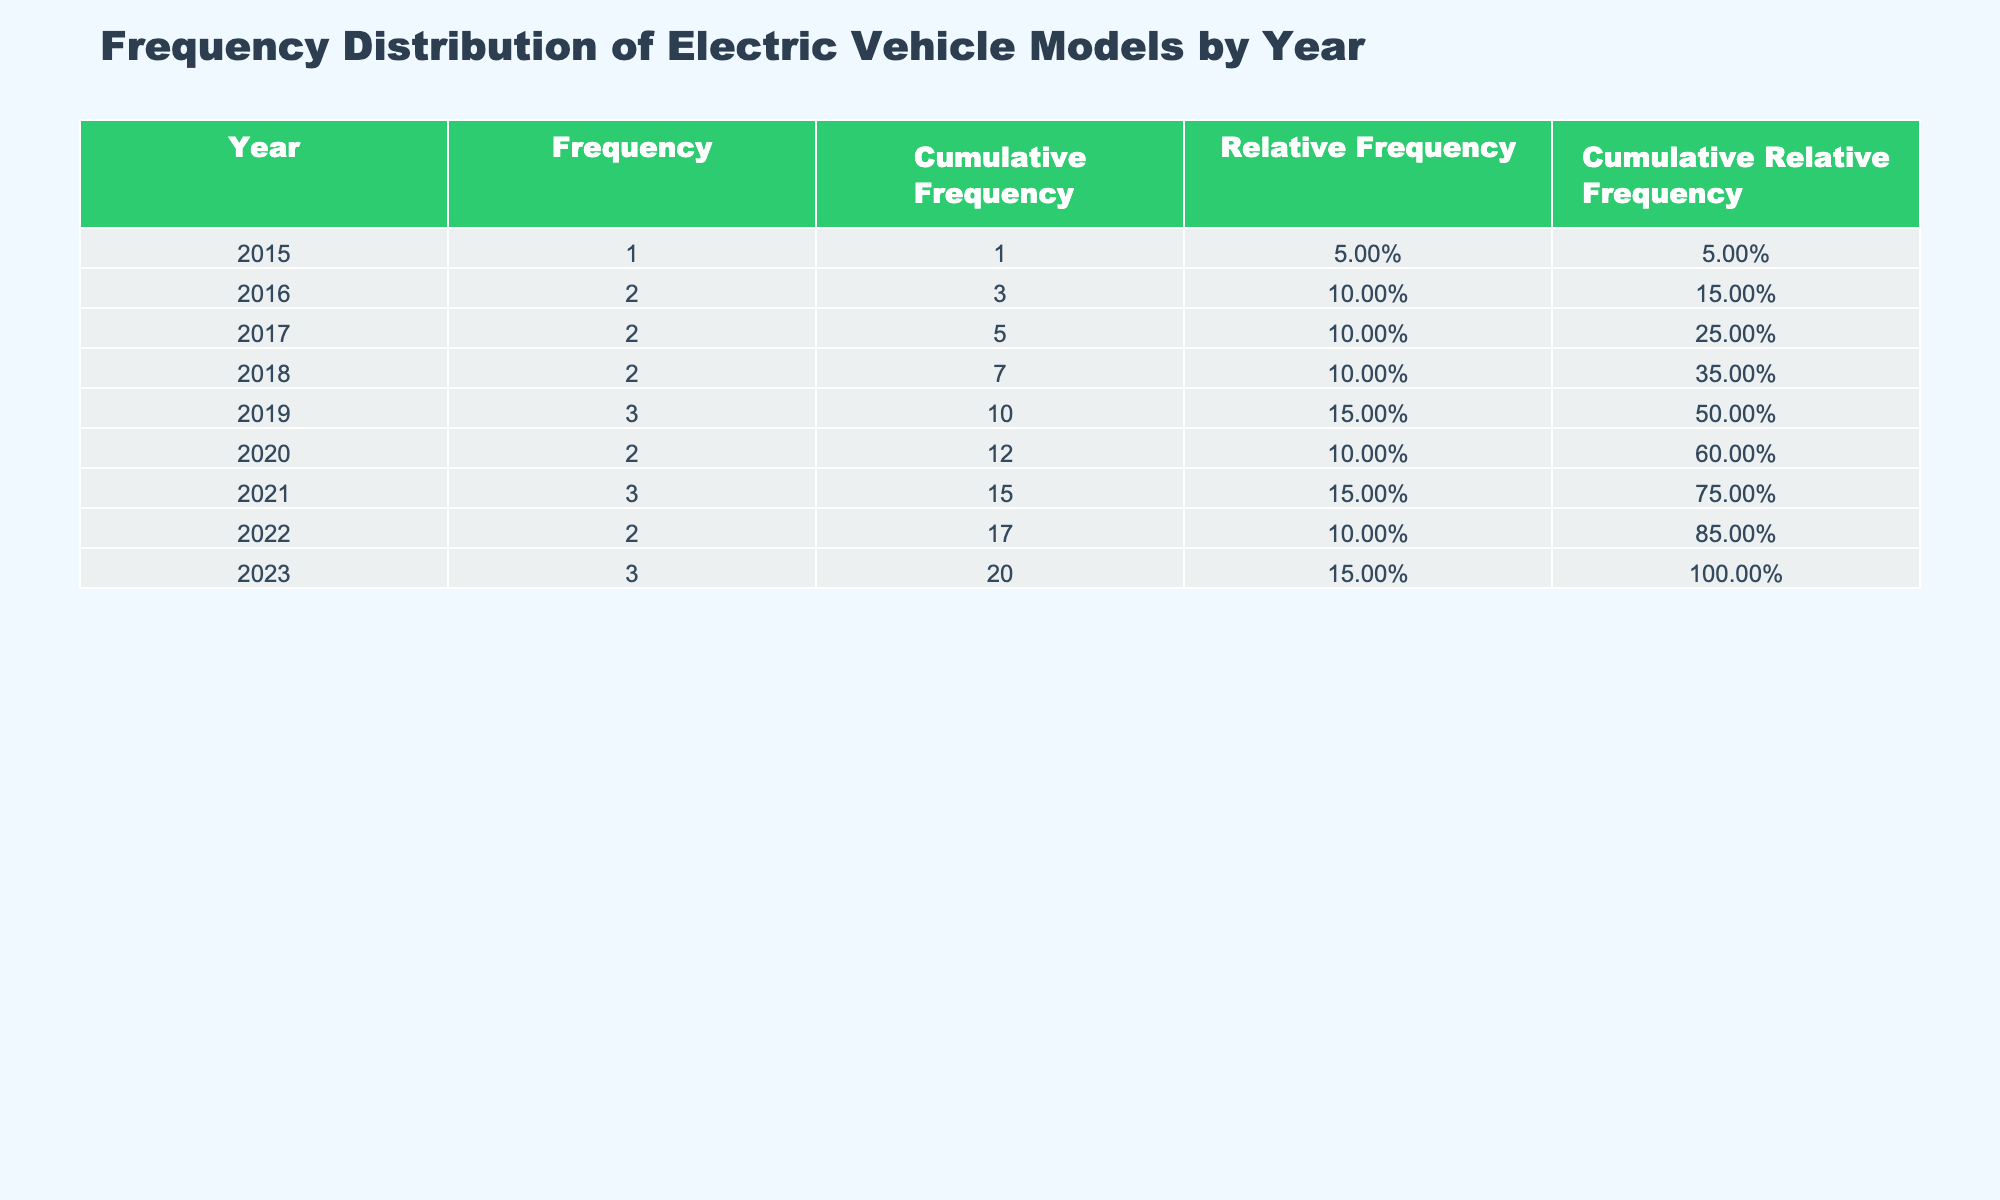What was the interest level for Tesla Model 3 in 2021? In the table, under the year 2021, I can see the interest level for the Tesla Model 3 listed as 70,000.
Answer: 70,000 How many different electric vehicle models are listed for the year 2020? Looking at the table, I find two models listed for the year 2020: Ford Mustang Mach-E and Tesla Model Y.
Answer: 2 What is the cumulative frequency of interest levels for electric vehicles up to the year 2019? To find the cumulative frequency for years up to 2019, I add the frequencies: 1 (2015) + 2 (2016) + 2 (2017) + 2 (2018) + 3 (2019) = 10.
Answer: 10 Did the interest level for electric vehicle models in 2022 exceed those of 2021? In the table, the interest level for 2022 (80,000 for the Tesla Model Y + 25,000 for Ford F-150 Lightning) is 105,000, while for 2021 (70,000 for Tesla Model 3 + 12,000 for Lucid Air + 18,000 for Volkswagen ID.4) it totals 100,000. So yes, 2022 exceeds 2021.
Answer: Yes What was the average interest level of all electric vehicle models in 2023? I add the interest levels for 2023: 22,000 (Hyundai Ioniq 5) + 15,000 (Chevrolet Equinox EV) + 30,000 (Tesla Cybertruck) = 67,000. There are three models, so the average is 67,000 / 3 ≈ 22,333.
Answer: 22,333 What year had the highest cumulative relative frequency? To find out the year with the highest cumulative relative frequency, I analyze the cumulative relative frequency for each year. The year with the highest value is 2022 with 100%.
Answer: 2022 Was the most popular model in 2019 the Tesla Model 3? In the year 2019, the Tesla Model 3 had the highest interest level of 50,000, compared to other models that had lower values (Hyundai Kona Electric with 9,000, Kia Niro EV with 8,000).
Answer: Yes What percentage of the total interest level does Tesla Model Y account for in 2020? The total interest levels noted in the table add to 320,000. The Tesla Model Y has an interest level of 60,000 in 2020. To find the percentage, I divide 60,000 by 320,000 and multiply by 100. So, (60,000 / 320,000) * 100 = 18.75%.
Answer: 18.75% 